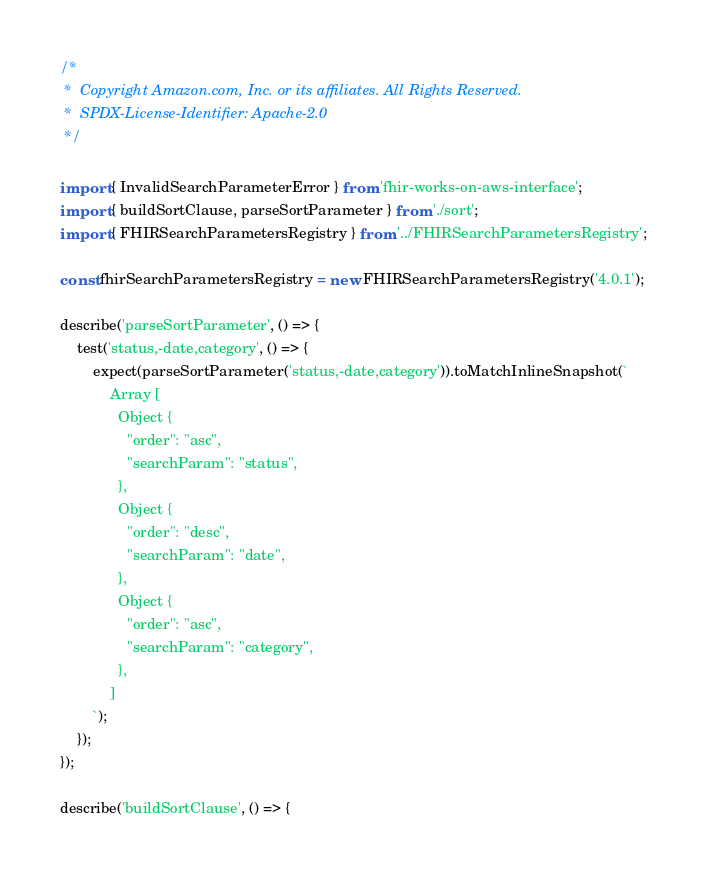Convert code to text. <code><loc_0><loc_0><loc_500><loc_500><_TypeScript_>/*
 *  Copyright Amazon.com, Inc. or its affiliates. All Rights Reserved.
 *  SPDX-License-Identifier: Apache-2.0
 */

import { InvalidSearchParameterError } from 'fhir-works-on-aws-interface';
import { buildSortClause, parseSortParameter } from './sort';
import { FHIRSearchParametersRegistry } from '../FHIRSearchParametersRegistry';

const fhirSearchParametersRegistry = new FHIRSearchParametersRegistry('4.0.1');

describe('parseSortParameter', () => {
    test('status,-date,category', () => {
        expect(parseSortParameter('status,-date,category')).toMatchInlineSnapshot(`
            Array [
              Object {
                "order": "asc",
                "searchParam": "status",
              },
              Object {
                "order": "desc",
                "searchParam": "date",
              },
              Object {
                "order": "asc",
                "searchParam": "category",
              },
            ]
        `);
    });
});

describe('buildSortClause', () => {</code> 